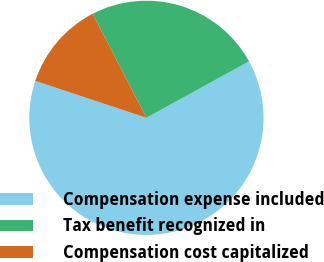<chart> <loc_0><loc_0><loc_500><loc_500><pie_chart><fcel>Compensation expense included<fcel>Tax benefit recognized in<fcel>Compensation cost capitalized<nl><fcel>63.11%<fcel>24.59%<fcel>12.3%<nl></chart> 